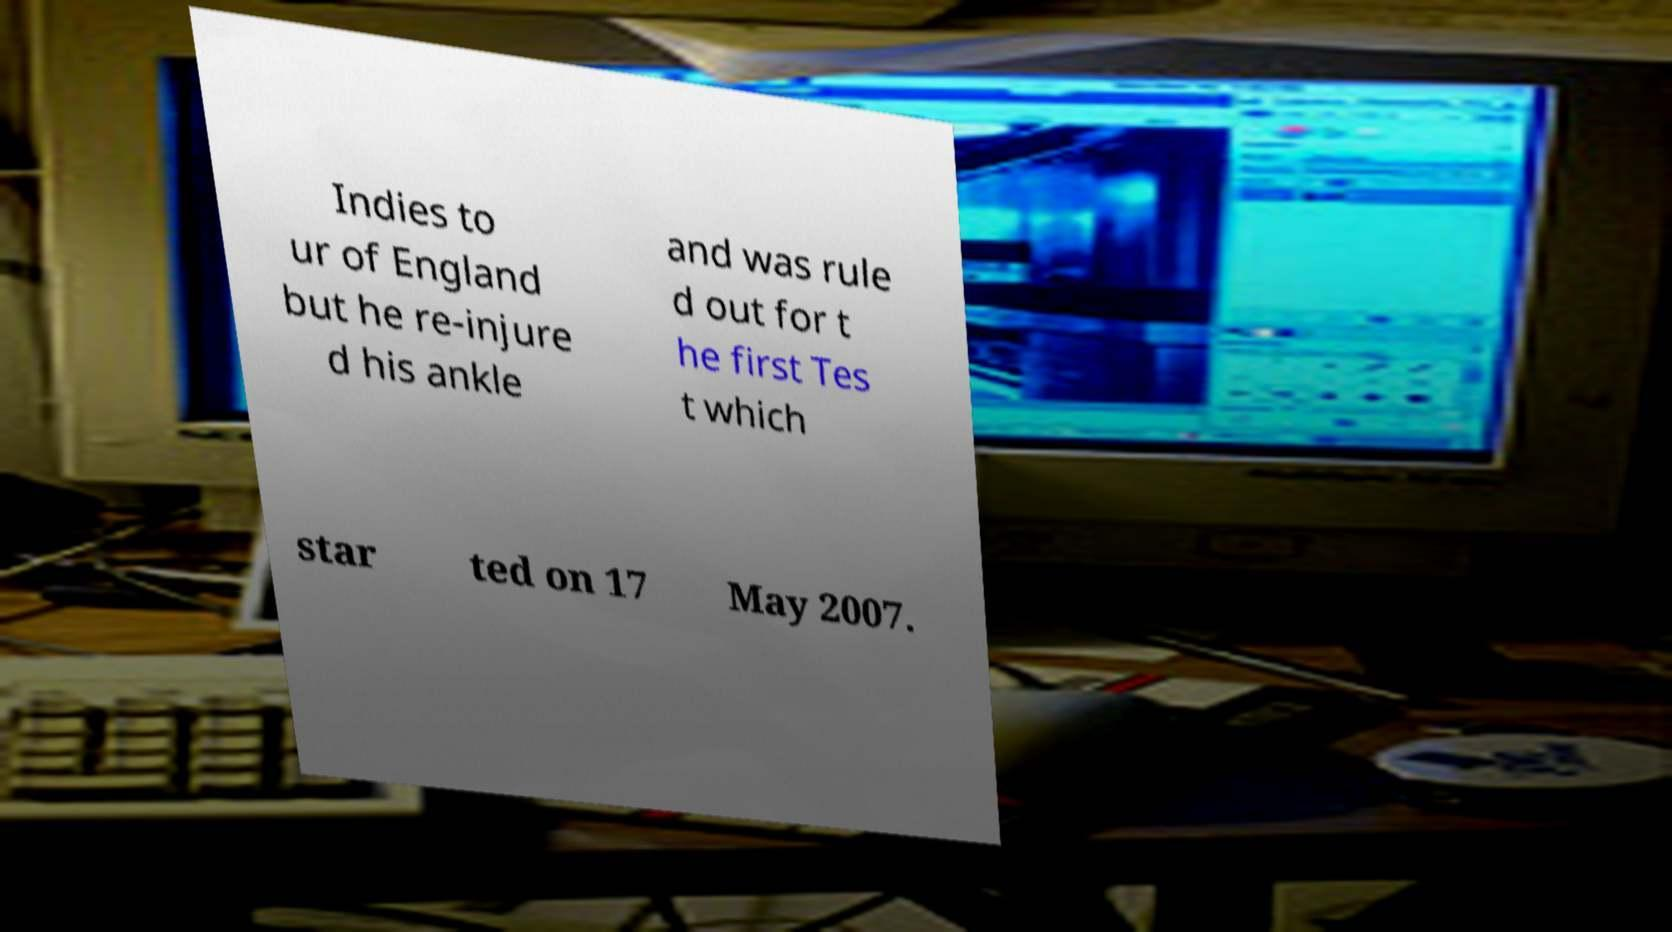Could you assist in decoding the text presented in this image and type it out clearly? Indies to ur of England but he re-injure d his ankle and was rule d out for t he first Tes t which star ted on 17 May 2007. 